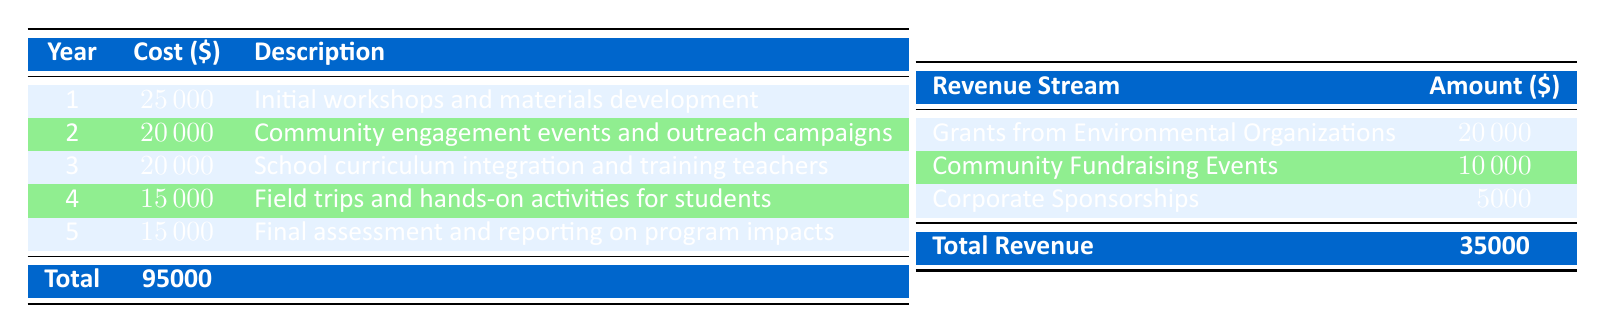What is the total cost of the educational outreach program? The table explicitly lists the total cost at the bottom, which is provided as $100,000.
Answer: 100000 Which year has the highest individual cost? Looking at the annual costs listed for each year, the highest cost is in year 1 at $25,000.
Answer: 1 What are the total revenue amounts from the three listed revenue streams? The total revenue combines all the revenue amounts: $20,000 + $10,000 + $5,000 = $35,000.
Answer: 35000 Is there a year where the cost of the program increased compared to the previous year? By analyzing the costs, the first year ($25,000) is greater than the second year ($20,000), indicating a decrease instead of an increase. Therefore, the answer is no.
Answer: No What was the overall funding shortfall for the program? The total cost is $100,000, and the total revenue is $35,000, leading to a shortfall calculated as $100,000 - $35,000 = $65,000.
Answer: 65000 How many community fundraising events contributed to the program's total revenue? The table states there is one instance of community fundraising events that contributed $10,000, so the answer is one event.
Answer: 1 Which year's cost is focused on hands-on activities for students? Referring to the table, year 4 is designated for field trips and hands-on activities for students, which is the specific description provided.
Answer: 4 What is the average cost of the program over the five-year duration? Summing all annual costs gives $95,000; dividing this by the 5 years yields an average cost of $19,000.
Answer: 19000 Which two revenue streams combined would cover the cost of year 2? Year 2 costs $20,000, and the first two revenue streams together provide $20,000 ($20,000 + $10,000). Thus, these two streams can cover it.
Answer: Grants from Environmental Organizations & Community Fundraising Events 